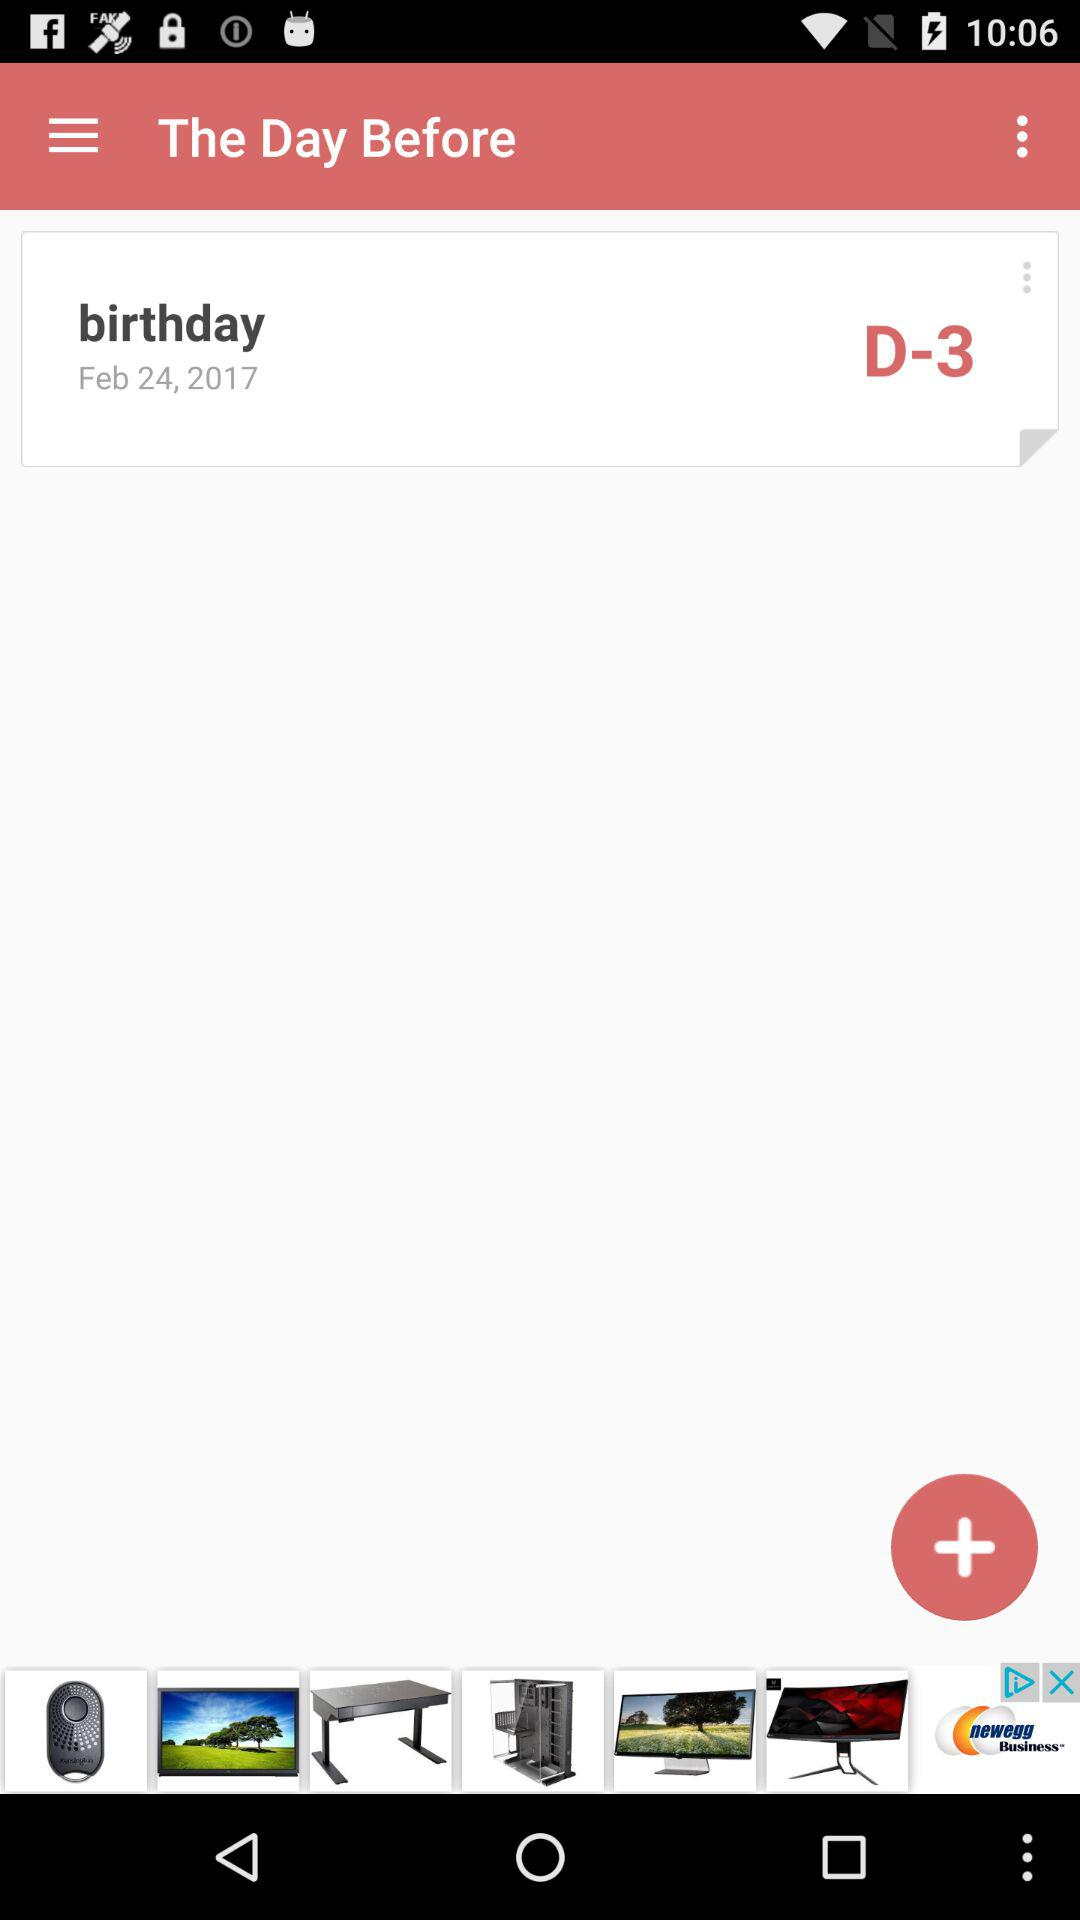What is the date of birthday? The date of birth is February 24, 2017. 